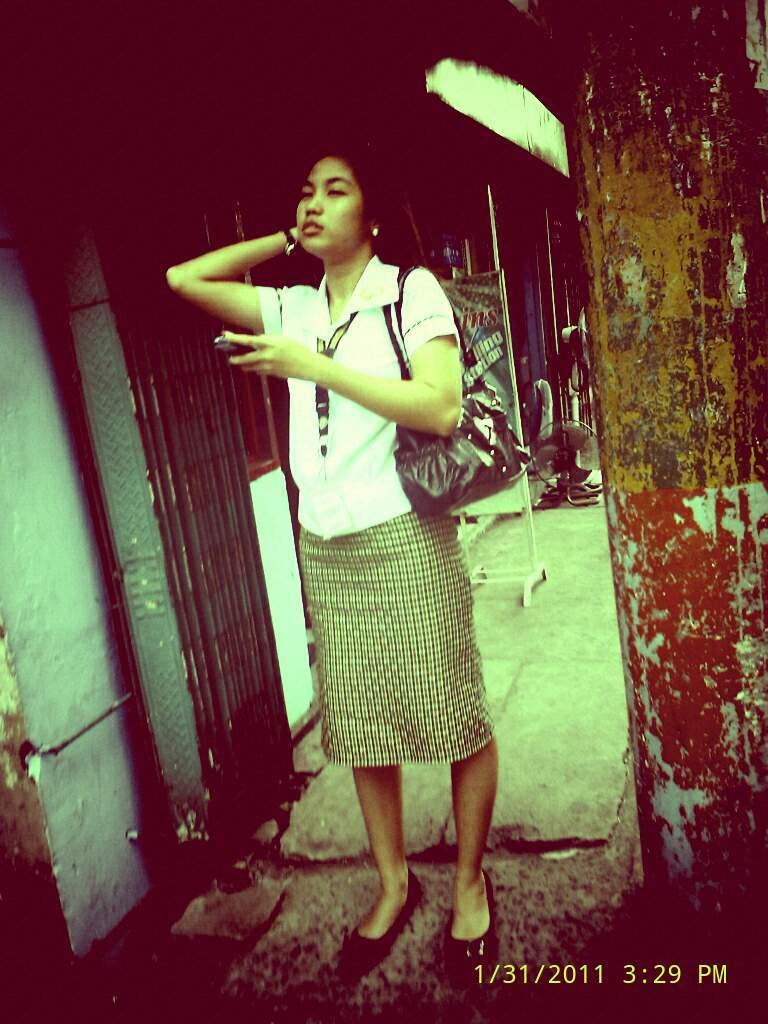Who is in the image? There is a person in the image, specifically a woman. What is the woman holding in the image? The woman has a bag in the image. What is the woman wearing in the image? The woman is wearing a white dress in the image. What decision does the woman make while sitting at the desk in the image? There is no desk present in the image, and the woman's actions or decisions cannot be determined from the provided facts. 